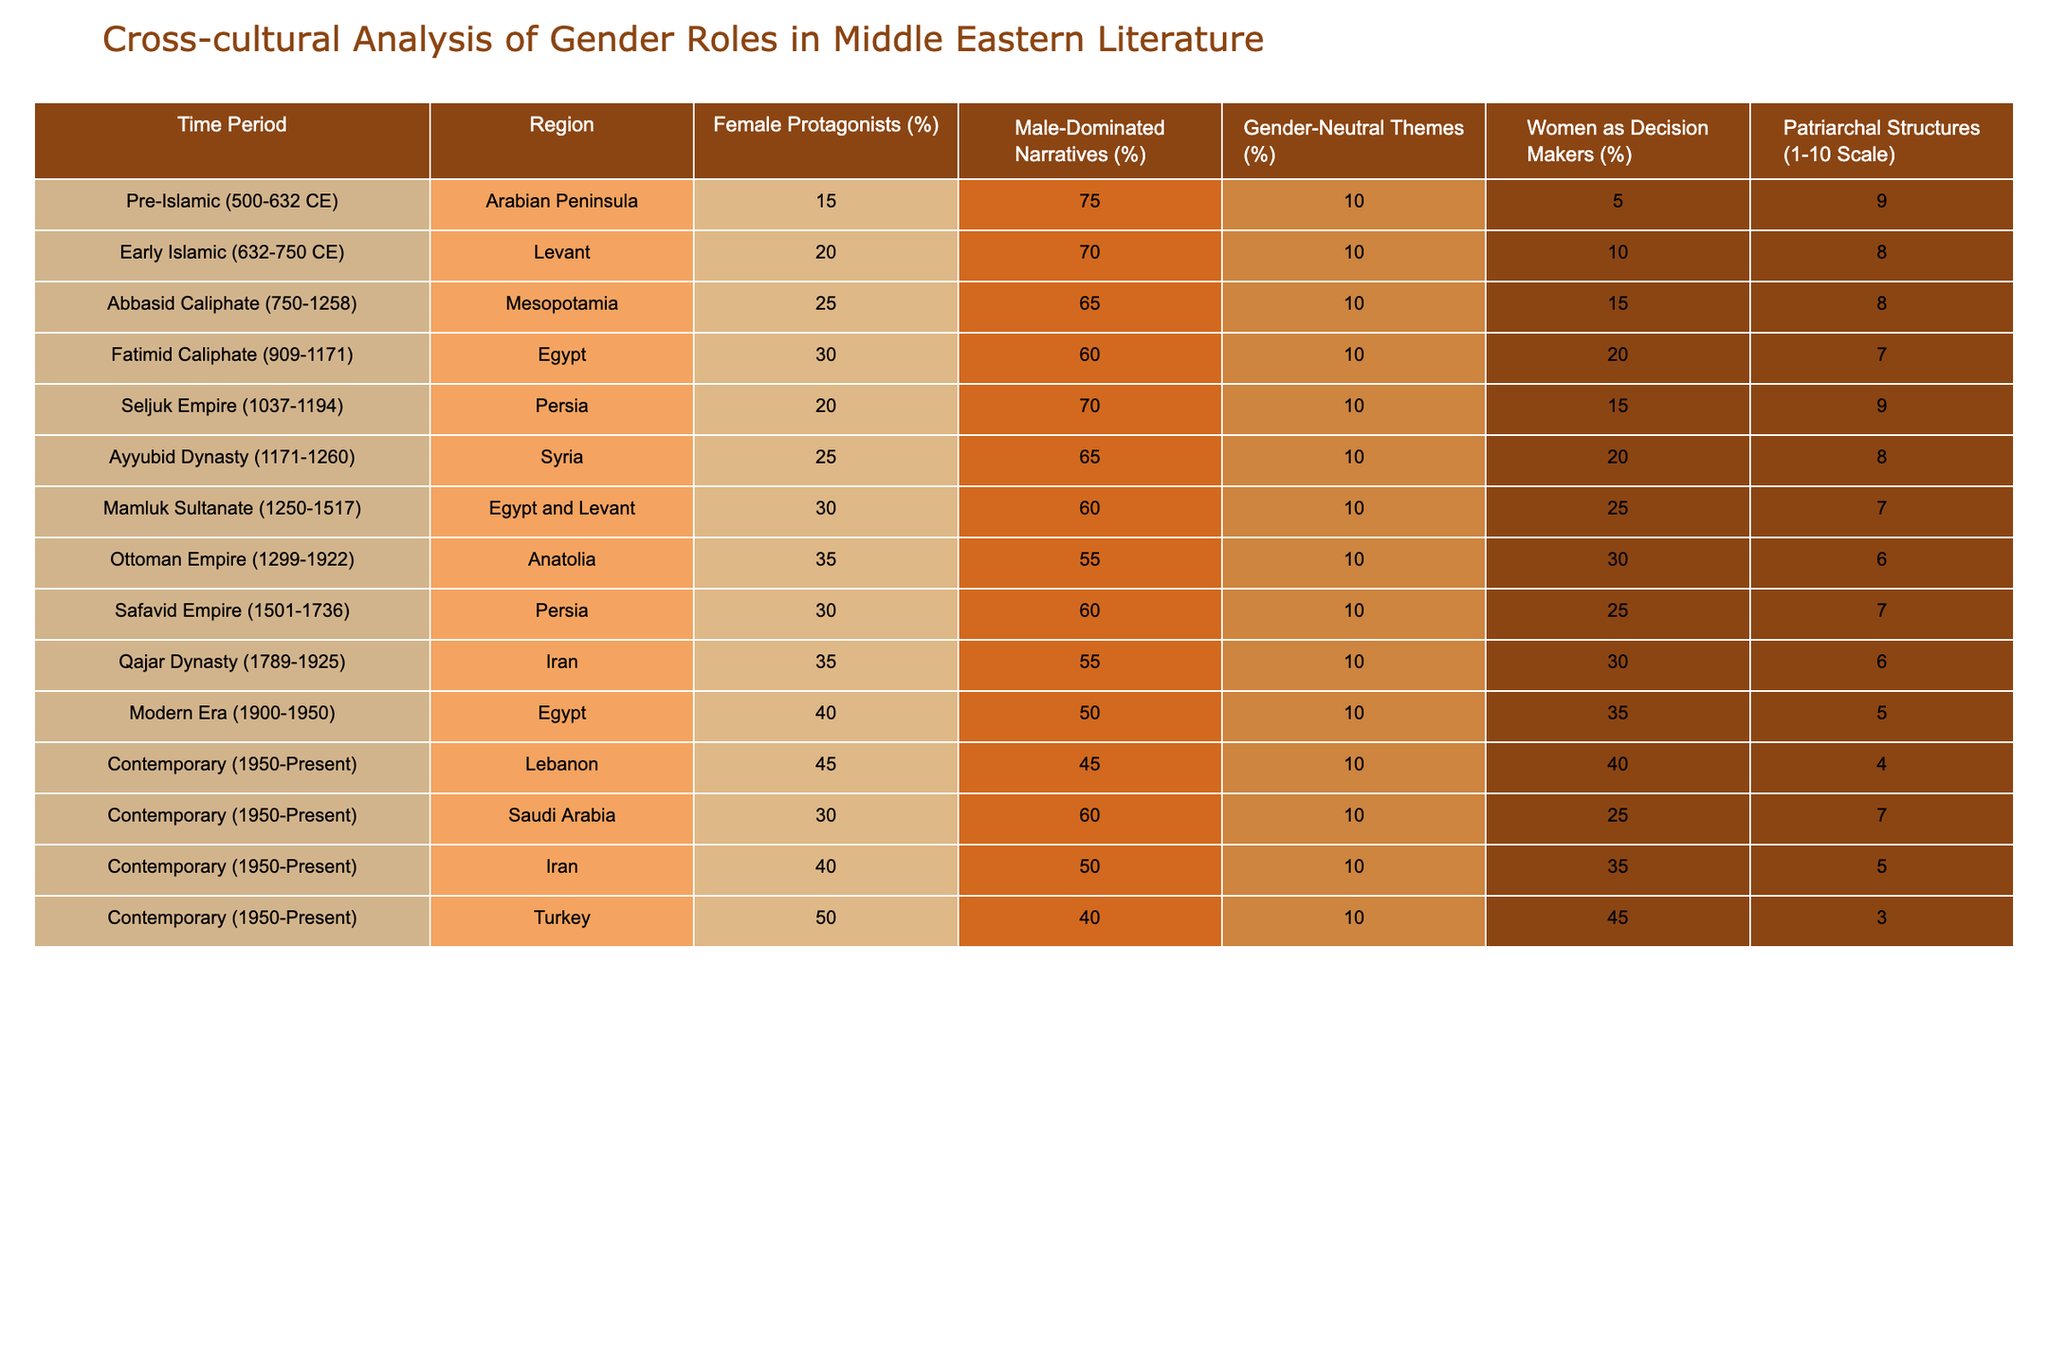What percentage of female protagonists is found in the Ottoman Empire? Referring to the table, the Ottoman Empire has a percentage of female protagonists of 35%.
Answer: 35% How does the role of women as decision makers change from the Pre-Islamic period to the Contemporary period in Turkey? In the Pre-Islamic period, women as decision makers is at 5%, while in the Contemporary period in Turkey, it jumps to 45%. This indicates a growth of 40 percentage points.
Answer: It increases by 40% Which time period has the highest percentage of male-dominated narratives? In the table, the Pre-Islamic time period shows the highest percentage of male-dominated narratives at 75%.
Answer: 75% True or False: The Fatimid Caliphate has more female protagonists than the Abbasid Caliphate. The Fatimid Caliphate has 30% female protagonists, while the Abbasid Caliphate has 25%. Therefore, this statement is true.
Answer: True What is the average percentage of female protagonists across the Modern Era and the Contemporary period in Lebanon? The Modern Era has 40% female protagonists and the Contemporary period in Lebanon has 45%. The average is (40 + 45)/2 = 42.5%.
Answer: 42.5% Which region during the Fatimid Caliphate has the least patriarchal structures and what is the scale rating? The Fatimid Caliphate is associated with Egypt, which has a patriarchal structures rating of 7 on a 1-10 scale, which is the lowest for that period.
Answer: 7 In what way do gender-neutral themes remain constant across all periods listed in the table? The percentage of gender-neutral themes is consistently 10% across all time periods listed in the table.
Answer: 10% What time period shows the largest improvement in women's roles as decision makers from the percentage standpoint when compared to the Pre-Islamic period? The Contemporary period in Turkey shows a significant increase in women's roles as decision makers to 45%, compared to only 5% in the Pre-Islamic period, a change of 40 percentage points.
Answer: 40 percentage points How do patriarchal structures compare between the Ottoman Empire and the Safavid Empire? The Ottoman Empire has a patriarchal structure rating of 6, while the Safavid Empire has a rating of 7. This indicates that the Ottoman Empire has less patriarchal structures than the Safavid Empire.
Answer: Ottoman Empire has less What region had the lowest percentage of female protagonists during the Early Islamic period? During the Early Islamic period, the Levant had 20% female protagonists, and there are no lower percentages recorded in that period for any region.
Answer: 20% What is the difference in the percentage of male-dominated narratives between the Contemporary period in Lebanon and Saudi Arabia? The percentage for Lebanon is 45%, whereas for Saudi Arabia it is 60%. The difference is 60 - 45 = 15%.
Answer: 15% 